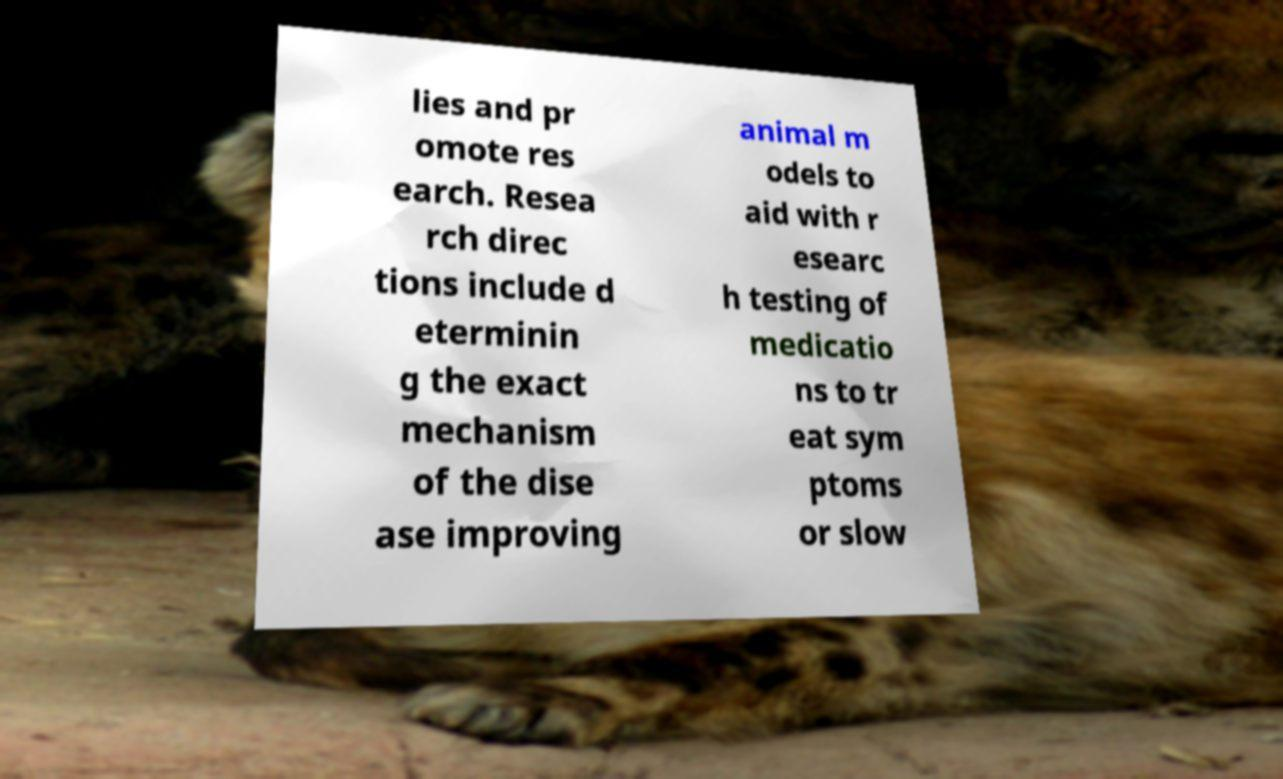Please read and relay the text visible in this image. What does it say? lies and pr omote res earch. Resea rch direc tions include d eterminin g the exact mechanism of the dise ase improving animal m odels to aid with r esearc h testing of medicatio ns to tr eat sym ptoms or slow 